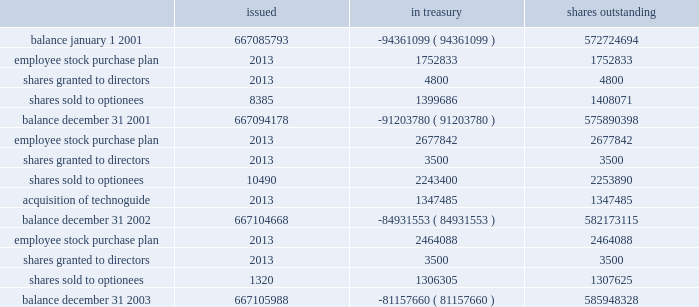Table of contents part ii , item 8 schlumberger limited ( schlumberger n.v. , incorporated in the netherlands antilles ) and subsidiary companies shares of common stock issued treasury shares outstanding .
See the notes to consolidated financial statements 39 / slb 2003 form 10-k .
What was amount of shares issued to directors during the period? 
Computations: ((4800 + 3500) + 3500)
Answer: 11800.0. 